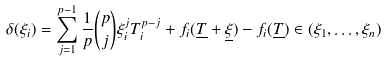Convert formula to latex. <formula><loc_0><loc_0><loc_500><loc_500>\delta ( \xi _ { i } ) = \sum _ { j = 1 } ^ { p - 1 } \frac { 1 } { p } \binom { p } { j } \xi _ { i } ^ { j } T _ { i } ^ { p - j } + f _ { i } ( \underline { T } + \underline { \xi } ) - f _ { i } ( \underline { T } ) \in ( \xi _ { 1 } , \dots , \xi _ { n } )</formula> 